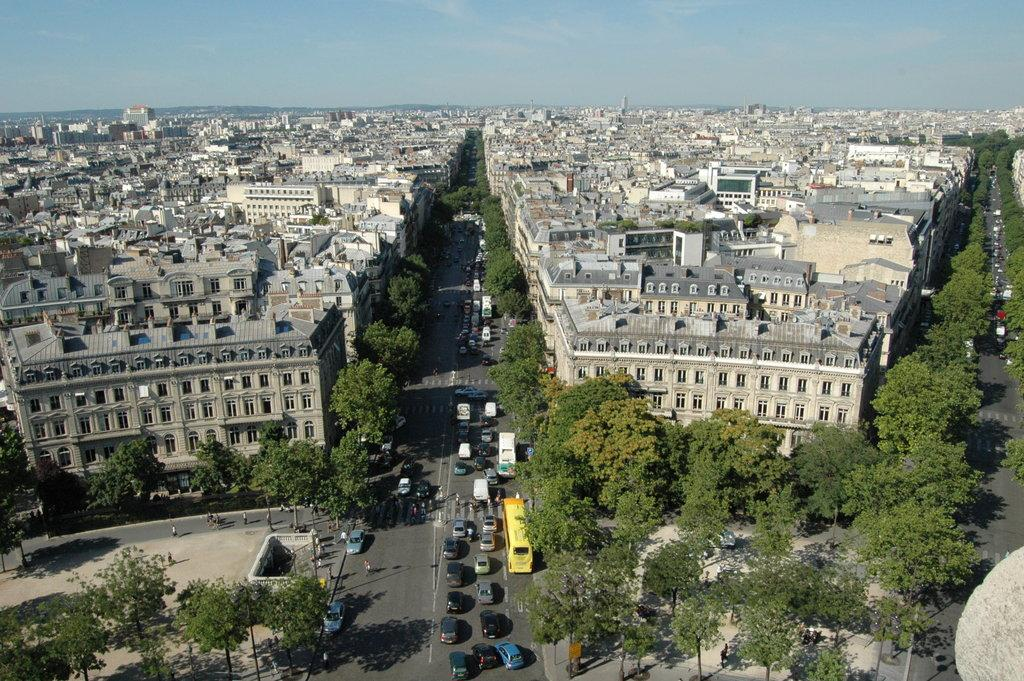What can be seen on the road in the image? There are vehicles and people on the road in the image. What structures are visible in the image? There are buildings visible in the image. What type of vegetation is present in the image? There are trees in the image. What else can be seen in the image besides the vehicles, people, buildings, and trees? There are some objects in the image. What is visible in the background of the image? The sky is visible in the background of the image. What type of string is being used to tie the cats together in the image? There are no cats present in the image, so there is no string being used to tie them together. What is the zinc content of the objects in the image? There is no information about the zinc content of the objects in the image, as it is not mentioned in the provided facts. 